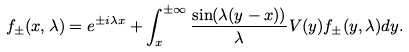Convert formula to latex. <formula><loc_0><loc_0><loc_500><loc_500>f _ { \pm } ( x , \lambda ) = e ^ { \pm i \lambda x } + \int _ { x } ^ { \pm \infty } \frac { \sin ( \lambda ( y - x ) ) } { \lambda } V ( y ) f _ { \pm } ( y , \lambda ) d y .</formula> 